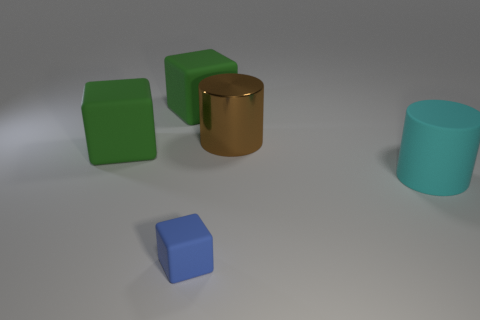There is a big object that is both on the right side of the small rubber object and in front of the metallic cylinder; what is its shape?
Your answer should be very brief. Cylinder. What number of tiny brown metal objects are there?
Ensure brevity in your answer.  0. What color is the tiny cube that is the same material as the cyan cylinder?
Keep it short and to the point. Blue. Are there more large brown cylinders than blue spheres?
Your response must be concise. Yes. Are there the same number of tiny blue blocks that are behind the cyan cylinder and big cyan rubber cylinders?
Offer a terse response. No. Is the size of the brown shiny cylinder the same as the cyan cylinder?
Give a very brief answer. Yes. There is a block that is in front of the brown metal cylinder and behind the small rubber thing; what is its color?
Offer a terse response. Green. What is the material of the green object behind the large rubber block in front of the big brown metal thing?
Provide a short and direct response. Rubber. Is the number of large brown objects less than the number of big cubes?
Your answer should be compact. Yes. Is the large green object in front of the brown cylinder made of the same material as the cyan thing?
Keep it short and to the point. Yes. 